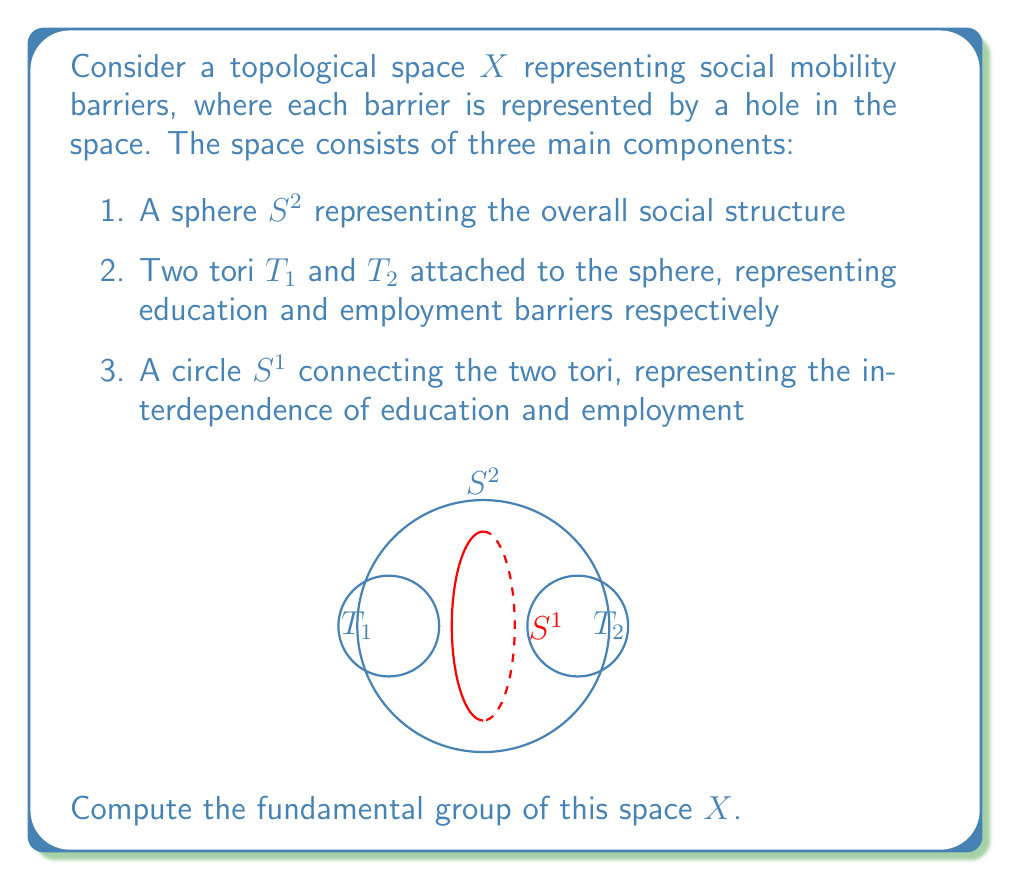What is the answer to this math problem? To compute the fundamental group of $X$, we'll use the Seifert-van Kampen theorem. Let's break this down step-by-step:

1) First, we need to choose suitable open sets that cover $X$. Let:
   - $U$ be the sphere $S^2$ with small neighborhoods of the attachment points of $T_1$, $T_2$, and $S^1$ removed
   - $V$ be the union of $T_1$, $T_2$, $S^1$, and small neighborhoods of their attachment points to $S^2$

2) $U \cap V$ is homotopy equivalent to three circles: two for the attachment points of $T_1$ and $T_2$, and one for $S^1$.

3) The fundamental groups of these spaces are:
   - $\pi_1(U) \cong \{e\}$ (trivial group, as $U$ is simply connected)
   - $\pi_1(V) \cong \pi_1(T_1) * \pi_1(T_2) * \pi_1(S^1) \cong (\mathbb{Z} \times \mathbb{Z}) * (\mathbb{Z} \times \mathbb{Z}) * \mathbb{Z}$
   - $\pi_1(U \cap V) \cong \mathbb{Z} * \mathbb{Z} * \mathbb{Z}$

4) Let $a_1, b_1$ be generators of $\pi_1(T_1)$, $a_2, b_2$ be generators of $\pi_1(T_2)$, and $c$ be the generator of $\pi_1(S^1)$.

5) The inclusion maps induce the following homomorphisms:
   - $i_1: \pi_1(U \cap V) \to \pi_1(U)$ is trivial
   - $i_2: \pi_1(U \cap V) \to \pi_1(V)$ maps the generators to $a_1, a_2, c$ respectively

6) Applying the Seifert-van Kampen theorem, we get:

   $\pi_1(X) \cong \pi_1(V) / \langle i_2(x) = i_1(x) \text{ for } x \in \pi_1(U \cap V) \rangle$

7) This simplifies to:

   $\pi_1(X) \cong (\mathbb{Z} \times \mathbb{Z}) * (\mathbb{Z} \times \mathbb{Z}) * \mathbb{Z} / \langle a_1 = a_2 = c = e \rangle$

8) After these identifications, we're left with two free generators: $b_1$ and $b_2$.

Therefore, the fundamental group of $X$ is isomorphic to the free group on two generators.
Answer: $\pi_1(X) \cong F_2 \cong \mathbb{Z} * \mathbb{Z}$ 